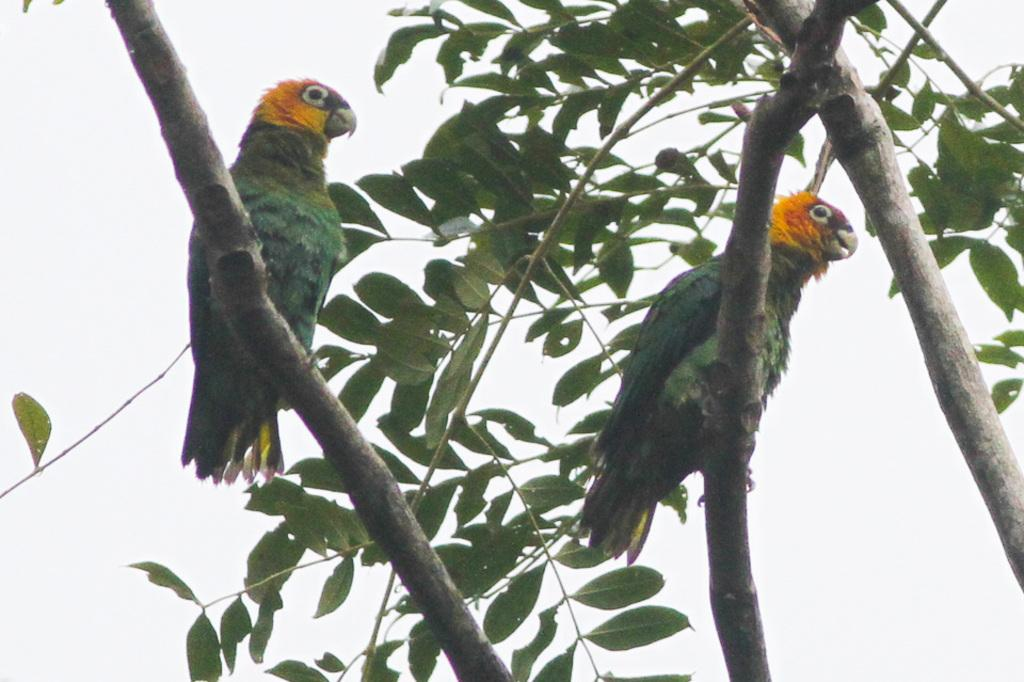What is the main subject of the image? The main subject of the image is the branches of a tree. Are there any living creatures present on the branches? Yes, there are two birds sitting on the branches. What type of sheet is being used to cover the attention of the birds in the image? There is no sheet or attention-covering object present in the image; it simply features branches with two birds sitting on them. 